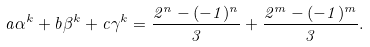Convert formula to latex. <formula><loc_0><loc_0><loc_500><loc_500>a \alpha ^ { k } + b \beta ^ { k } + c \gamma ^ { k } = \frac { 2 ^ { n } - ( - 1 ) ^ { n } } { 3 } + \frac { 2 ^ { m } - ( - 1 ) ^ { m } } { 3 } .</formula> 